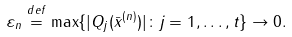Convert formula to latex. <formula><loc_0><loc_0><loc_500><loc_500>\varepsilon _ { n } \stackrel { d e f } { = } \max \{ | Q _ { j } ( \bar { x } ^ { ( n ) } ) | \colon j = 1 , \dots , t \} \rightarrow 0 .</formula> 